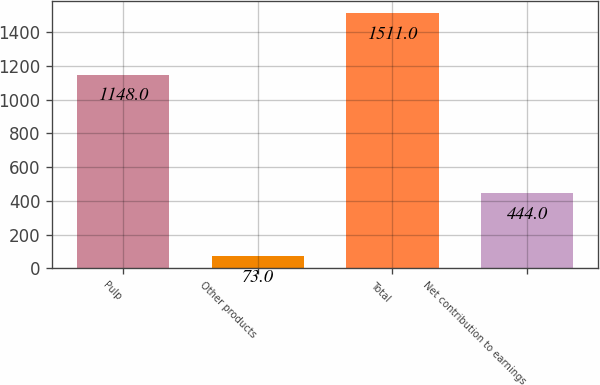Convert chart. <chart><loc_0><loc_0><loc_500><loc_500><bar_chart><fcel>Pulp<fcel>Other products<fcel>Total<fcel>Net contribution to earnings<nl><fcel>1148<fcel>73<fcel>1511<fcel>444<nl></chart> 